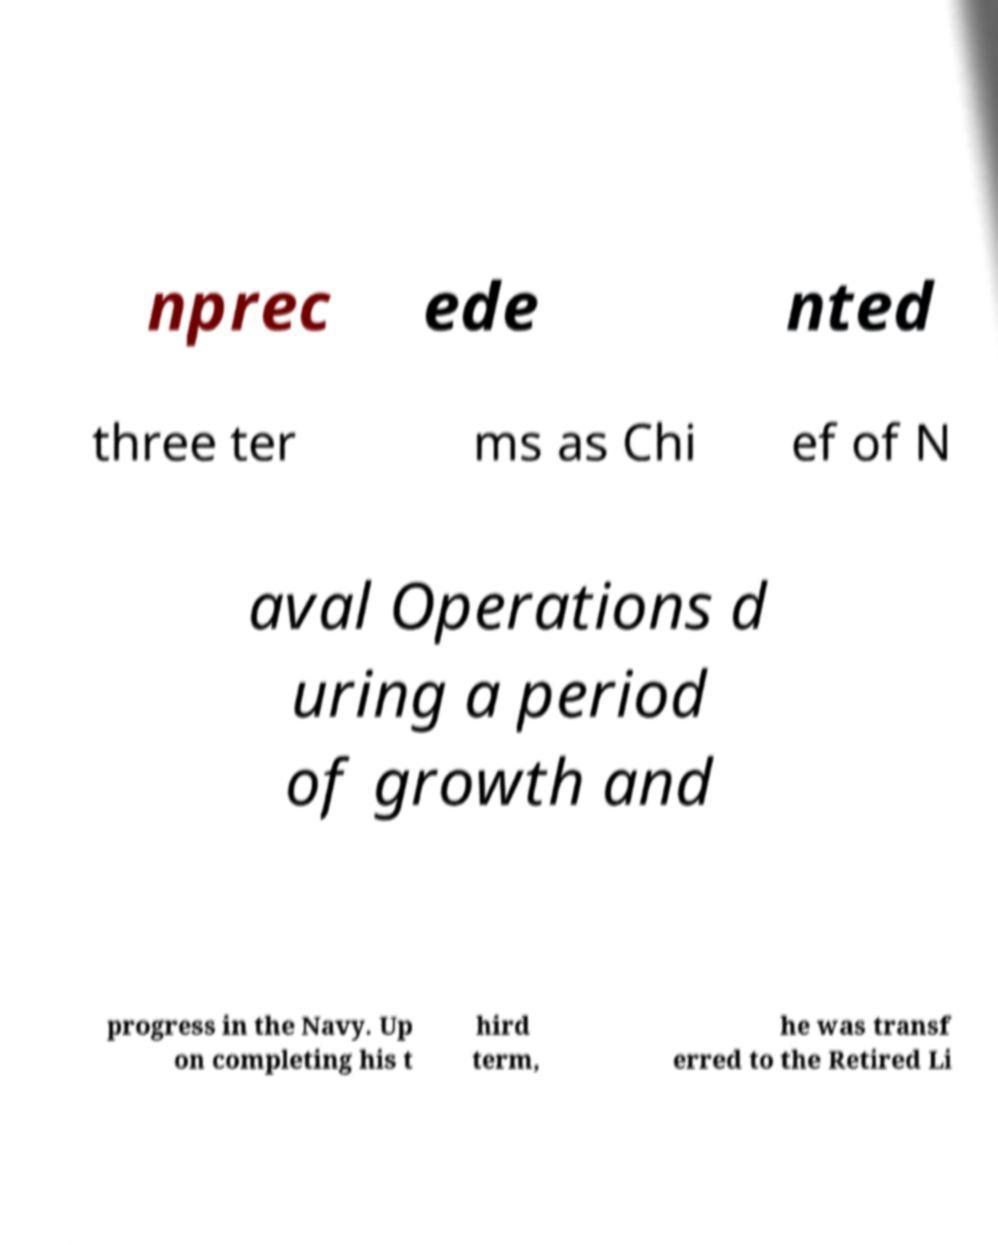Please identify and transcribe the text found in this image. nprec ede nted three ter ms as Chi ef of N aval Operations d uring a period of growth and progress in the Navy. Up on completing his t hird term, he was transf erred to the Retired Li 